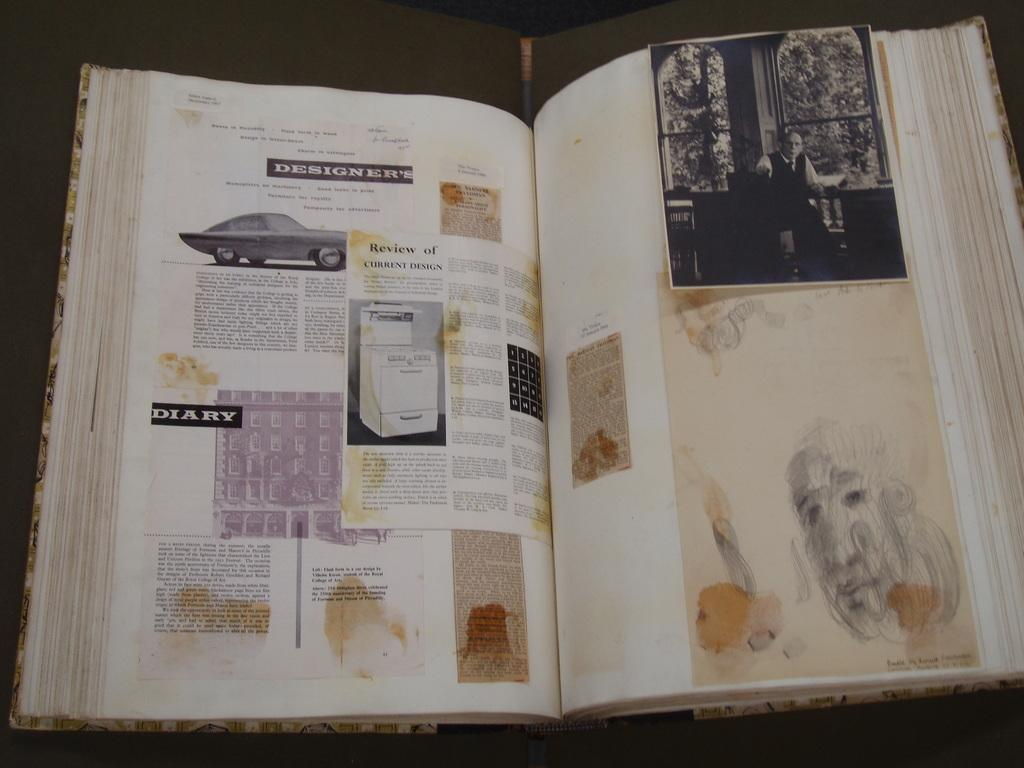Provide a one-sentence caption for the provided image. A scrapbook that has various articles pasted in it and one is titled Designers. 